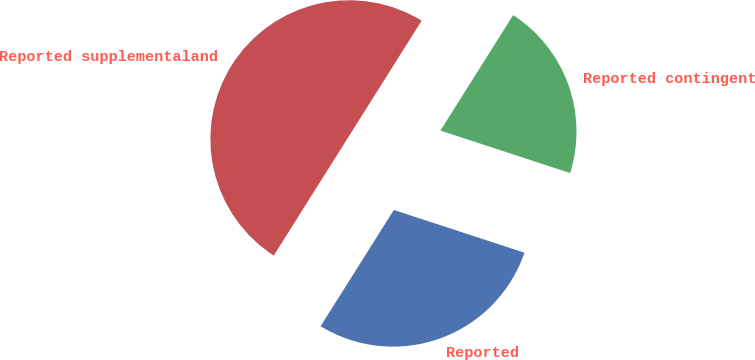<chart> <loc_0><loc_0><loc_500><loc_500><pie_chart><fcel>Reported<fcel>Reported contingent<fcel>Reported supplementaland<nl><fcel>28.91%<fcel>21.09%<fcel>50.0%<nl></chart> 